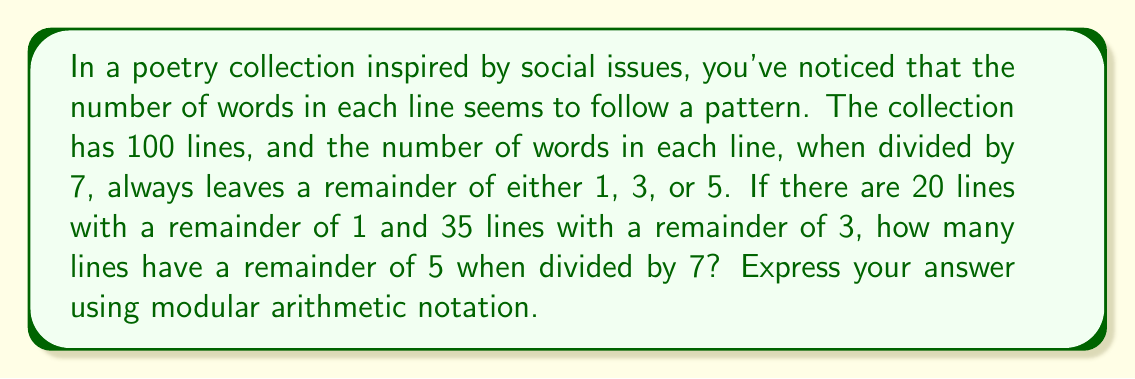Provide a solution to this math problem. Let's approach this step-by-step:

1) We know that there are 100 lines in total.

2) The number of words in each line, when divided by 7, gives a remainder of either 1, 3, or 5.

3) We're told that:
   - 20 lines have a remainder of 1
   - 35 lines have a remainder of 3
   - The rest have a remainder of 5

4) Let $x$ be the number of lines with a remainder of 5.

5) We can set up an equation:
   $20 + 35 + x = 100$

6) Solving for $x$:
   $x = 100 - 20 - 35 = 45$

7) Now, we need to express this using modular arithmetic notation.

8) In modular arithmetic, we say that two numbers are congruent modulo $n$ if they have the same remainder when divided by $n$.

9) 45 divided by 7 gives a quotient of 6 and a remainder of 3.

10) Therefore, in modular arithmetic notation, we can express this as:
    $45 \equiv 3 \pmod{7}$

This means that 45 is congruent to 3 modulo 7, or in other words, 45 and 3 have the same remainder when divided by 7.
Answer: $45 \equiv 3 \pmod{7}$ 